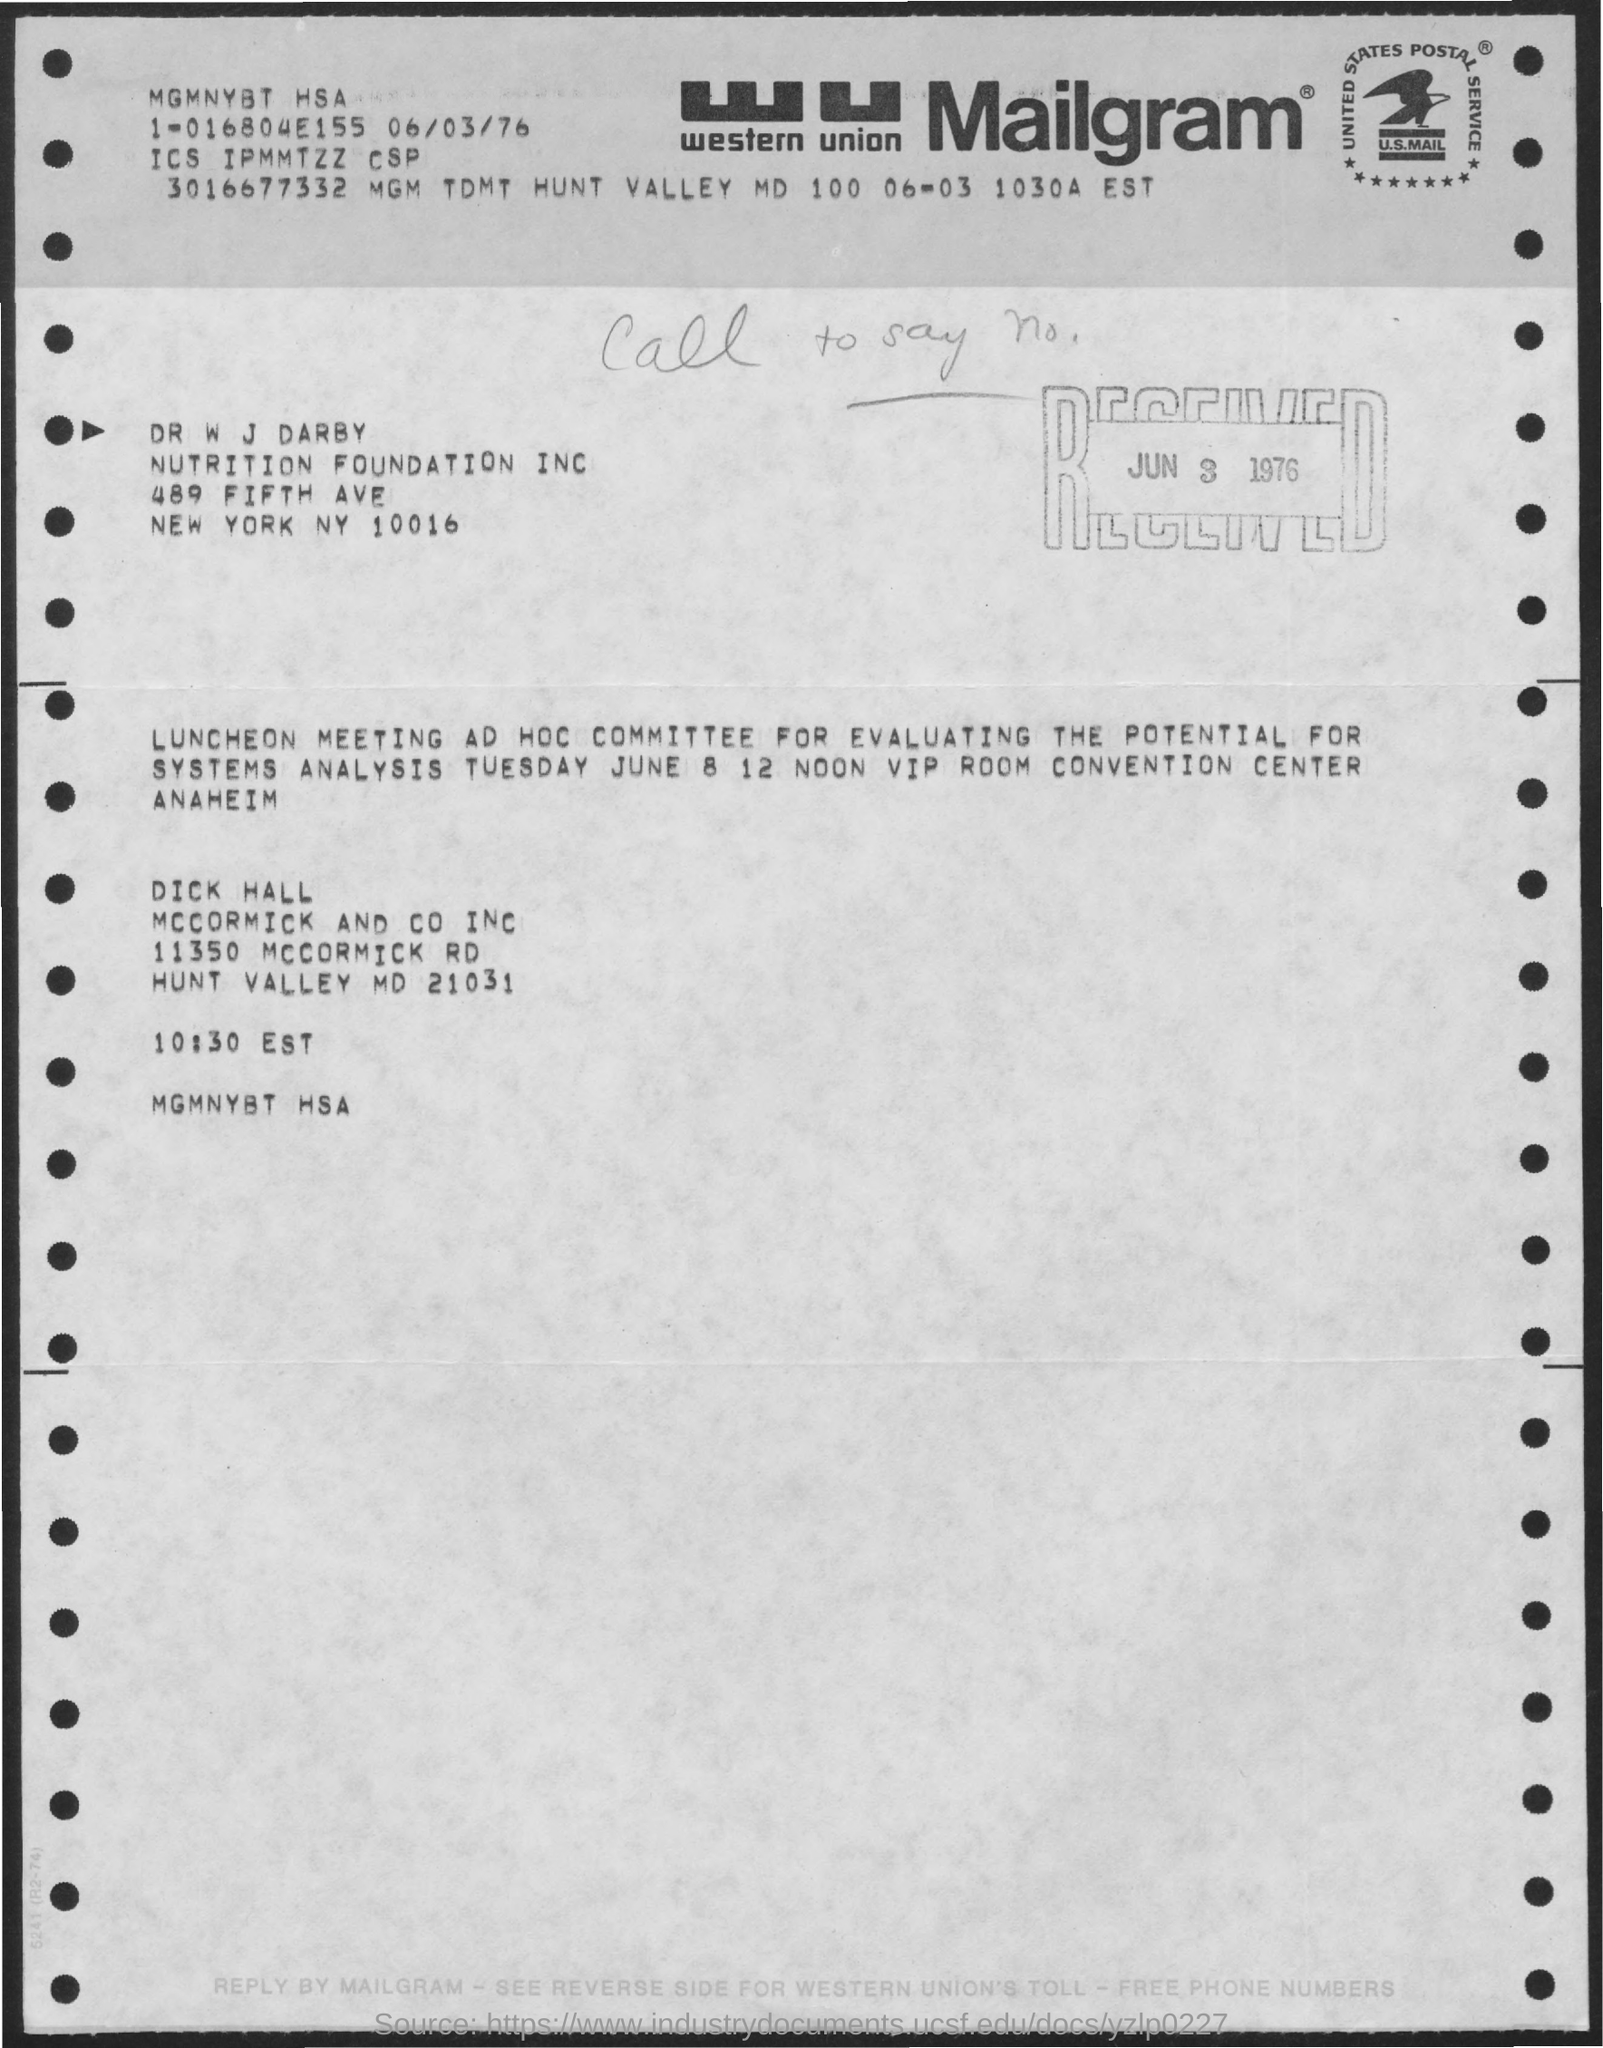What does wu stand for ?
Your answer should be compact. Western Union. What day of the week is mentioned in the document?
Your answer should be compact. Tuesday. 